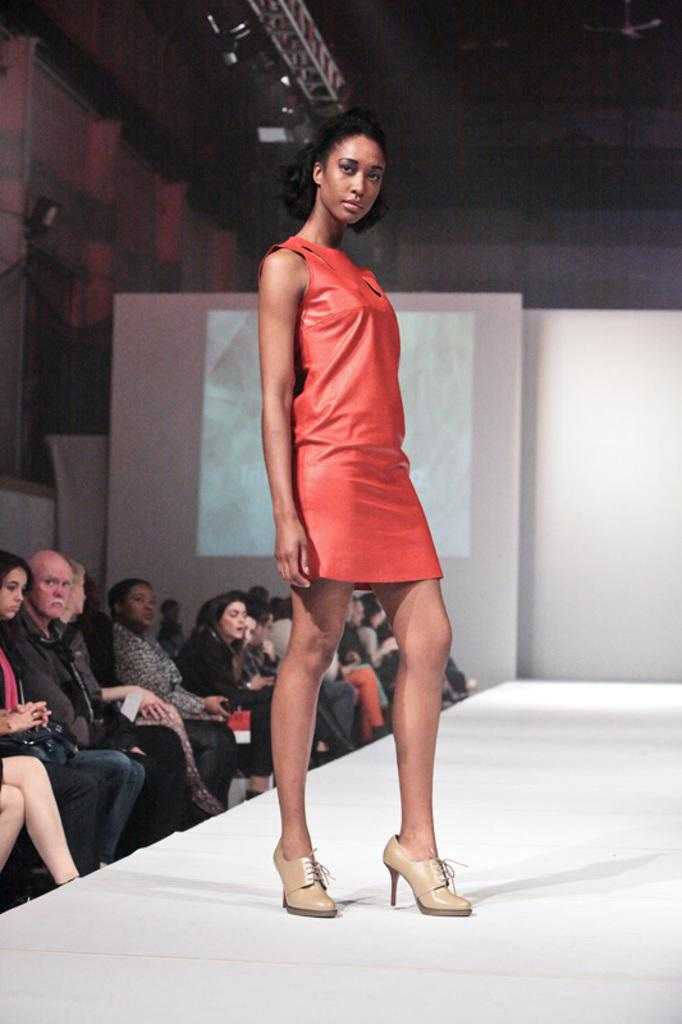What is the lady in the image doing? The lady is standing on a ramp in the image. What can be seen on the left side of the image? People are sitting on chairs on the left side of the image. What is visible in the background of the image? There is a white curtain in the background of the image. What type of jeans is the lady wearing in the image? There is no information about the lady's jeans in the image, so we cannot determine what type she is wearing. Can you tell me what letter the lady is holding in the image? There is no letter present in the image; the lady is simply standing on a ramp. 